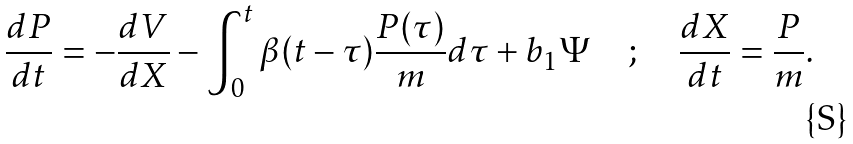<formula> <loc_0><loc_0><loc_500><loc_500>\frac { d P } { d t } = - \frac { d V } { d X } - \int _ { 0 } ^ { t } \beta ( t - \tau ) \frac { P ( \tau ) } { m } d \tau + b _ { 1 } \Psi \quad ; \quad \frac { d X } { d t } = \frac { P } { m } .</formula> 